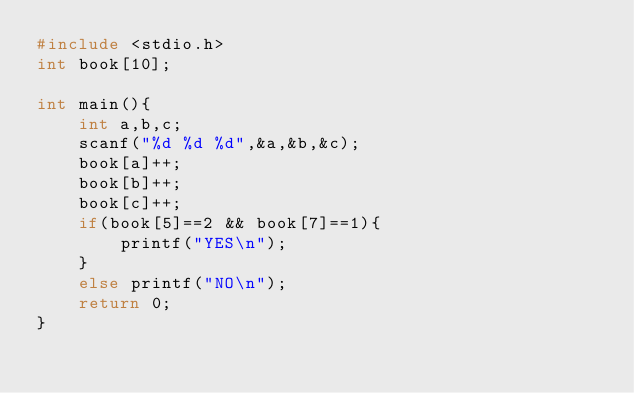Convert code to text. <code><loc_0><loc_0><loc_500><loc_500><_C_>#include <stdio.h>
int book[10];

int main(){
    int a,b,c;
    scanf("%d %d %d",&a,&b,&c);
    book[a]++;
    book[b]++;
    book[c]++;
    if(book[5]==2 && book[7]==1){
        printf("YES\n");
    }
    else printf("NO\n");
    return 0;
}
</code> 